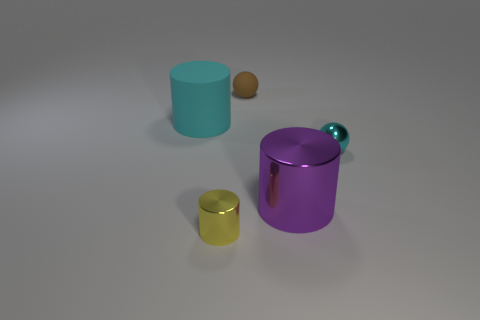What number of objects are cyan things right of the big purple metal object or big blue matte balls?
Offer a terse response. 1. There is a cyan cylinder behind the small metal thing that is behind the tiny shiny object in front of the metal ball; what size is it?
Your answer should be very brief. Large. There is a ball that is the same color as the big rubber cylinder; what is its material?
Offer a terse response. Metal. Is there any other thing that has the same shape as the yellow shiny thing?
Ensure brevity in your answer.  Yes. How big is the cyan object that is right of the cyan thing on the left side of the yellow shiny cylinder?
Provide a succinct answer. Small. How many small things are either metallic spheres or cyan rubber things?
Your response must be concise. 1. Is the number of cyan cylinders less than the number of large objects?
Offer a very short reply. Yes. Is there anything else that is the same size as the cyan sphere?
Offer a very short reply. Yes. Is the large matte object the same color as the big shiny cylinder?
Make the answer very short. No. Is the number of tiny blue shiny objects greater than the number of cyan metal things?
Keep it short and to the point. No. 